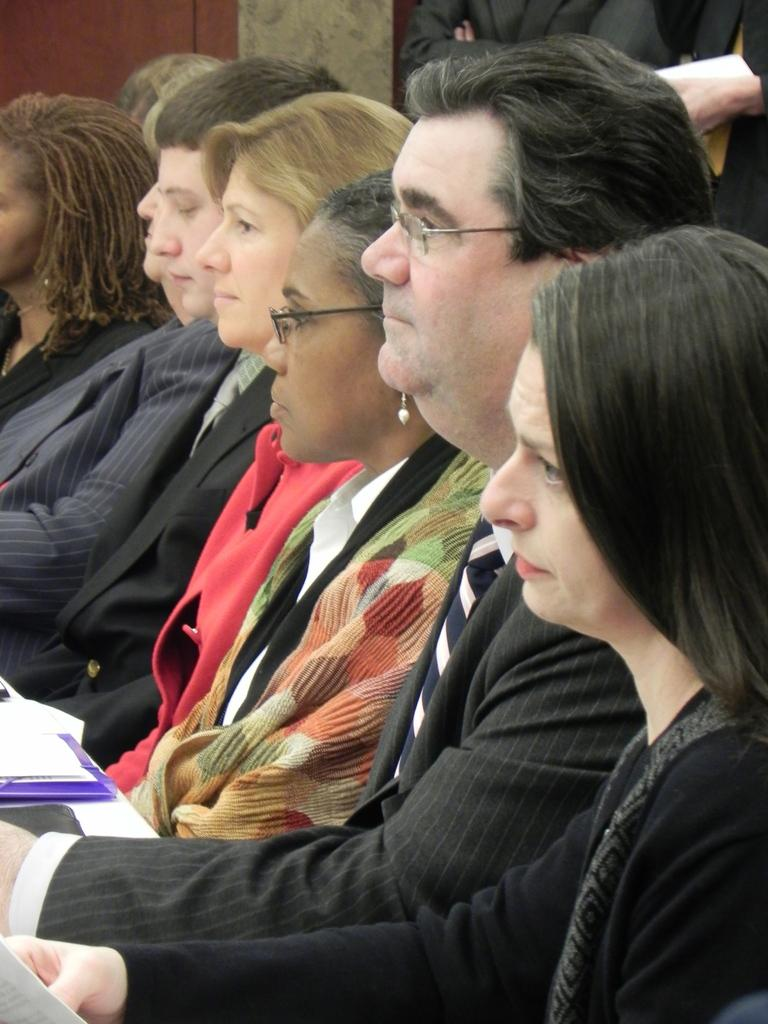What are the people in the image doing? The people in the image are sitting on chairs. Are there any other people in the image besides those sitting on chairs? Yes, there are people standing in the background of the image. What can be seen behind the people sitting on chairs? There is a wall visible in the image. What type of cakes are being served to the people sitting on chairs in the image? There is no mention of cakes or any food being served in the image. 